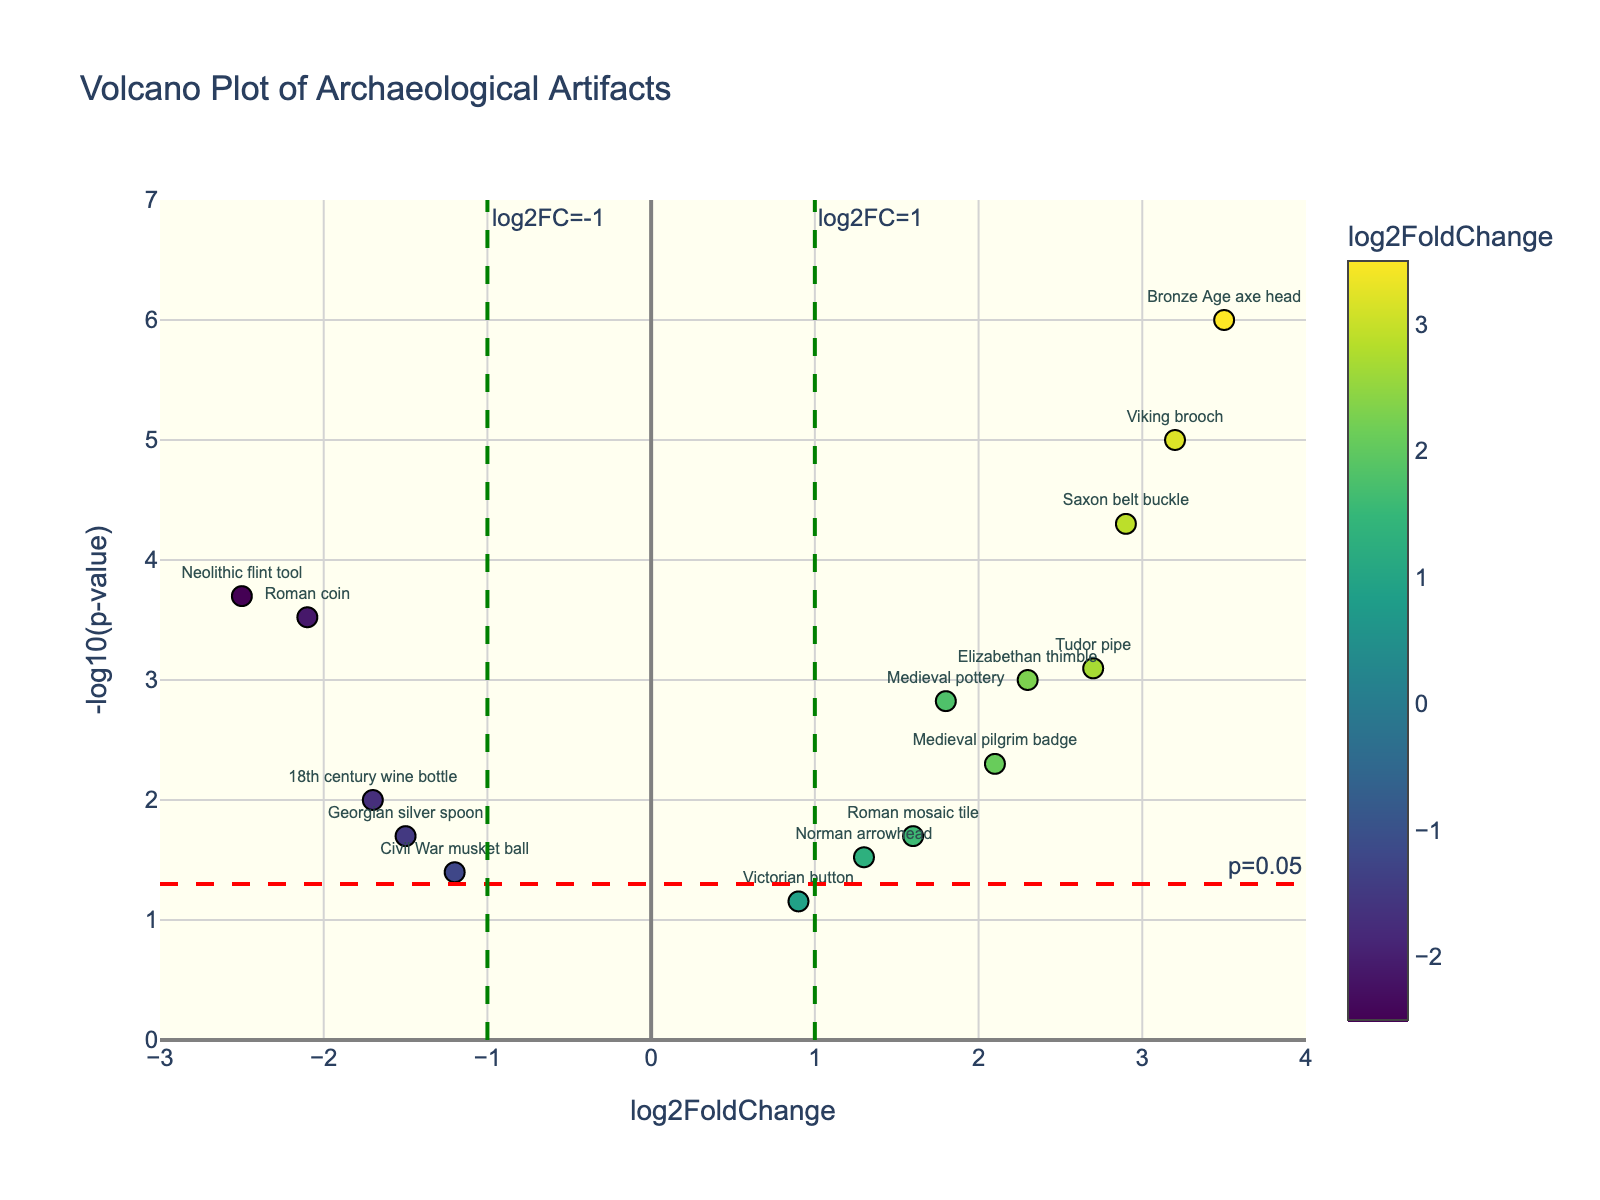How many artifacts are plotted on the Volcano Plot? Count the number of data points labeled with artifacts.
Answer: 14 What is the title of the figure? Look at the title at the top of the figure.
Answer: Volcano Plot of Archaeological Artifacts Which artifact has the highest log2FoldChange value? Identify the data point with the highest x-coordinate (log2FoldChange) and refer to the artifact label.
Answer: Bronze Age axe head How many artifacts have a log2FoldChange value greater than 1? Count the data points that are to the right of the line at log2FoldChange = 1.
Answer: 7 What is the p-value threshold indicated by the horizontal red line? Look at the annotation text next to the horizontal red dashed line.
Answer: 0.05 Which artifact has the lowest p-value? Find the data point with the highest y-coordinate (smallest p-value expressed as -log10(p-value)) and refer to the artifact label.
Answer: Bronze Age axe head Are the majority of artifacts above or below the p-value threshold? Count the number of data points above and below the horizontal red dashed line.
Answer: Above How many artifacts have both p-values less than 0.05 and log2FoldChange values greater than 2? Identify and count the data points to the right of log2FoldChange = 2 and above the horizontal red dashed line.
Answer: 4 Which artifact located within log2FoldChange [-1, 1] has the lowest p-value? Identify the data points between the vertical green lines at log2FoldChange = -1 and log2FoldChange = 1, then find the one with the highest y-coordinate.
Answer: Roman coin Explain the historical significance of Saxon belt buckle based on the plot. The Saxon belt buckle has a high log2FoldChange of 2.9 and a very low p-value (high -log10(p-value)), indicating it is a significant and unique find compared to other local excavations.
Answer: Significant and unique find 